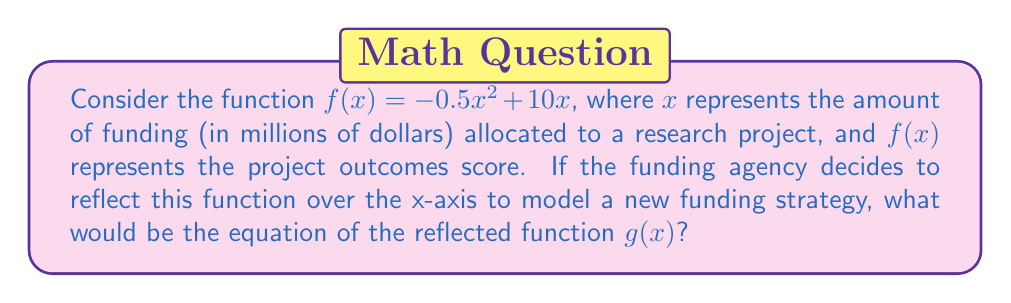What is the answer to this math problem? To find the reflection of the function $f(x)$ over the x-axis, we need to follow these steps:

1. The general form of reflecting a function $f(x)$ over the x-axis is $g(x) = -f(x)$.

2. Given function: $f(x) = -0.5x^2 + 10x$

3. Apply the reflection:
   $g(x) = -f(x)$
   $g(x) = -(-0.5x^2 + 10x)$

4. Distribute the negative sign:
   $g(x) = 0.5x^2 - 10x$

This reflection represents a scenario where the relationship between funding and project outcomes is inverted, which could be used to model an alternative funding strategy or to compare terrestrial and oceanographic studies with different funding-outcome relationships.
Answer: $g(x) = 0.5x^2 - 10x$ 